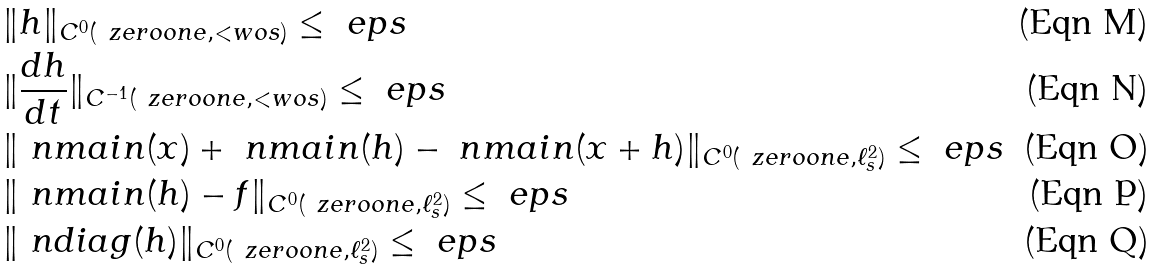Convert formula to latex. <formula><loc_0><loc_0><loc_500><loc_500>& \| h \| _ { C ^ { 0 } ( \ z e r o o n e , < w o s ) } \leq \ e p s \\ & \| \frac { d h } { d t } \| _ { C ^ { - 1 } ( \ z e r o o n e , < w o s ) } \leq \ e p s \\ & \| \ n m a i n ( x ) + \ n m a i n ( h ) - \ n m a i n ( x + h ) \| _ { C ^ { 0 } ( \ z e r o o n e , \ell ^ { 2 } _ { s } ) } \leq \ e p s \\ & \| \ n m a i n ( h ) - f \| _ { C ^ { 0 } ( \ z e r o o n e , \ell ^ { 2 } _ { s } ) } \leq \ e p s \\ & \| \ n d i a g ( h ) \| _ { C ^ { 0 } ( \ z e r o o n e , \ell ^ { 2 } _ { s } ) } \leq \ e p s</formula> 